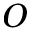Convert formula to latex. <formula><loc_0><loc_0><loc_500><loc_500>O</formula> 